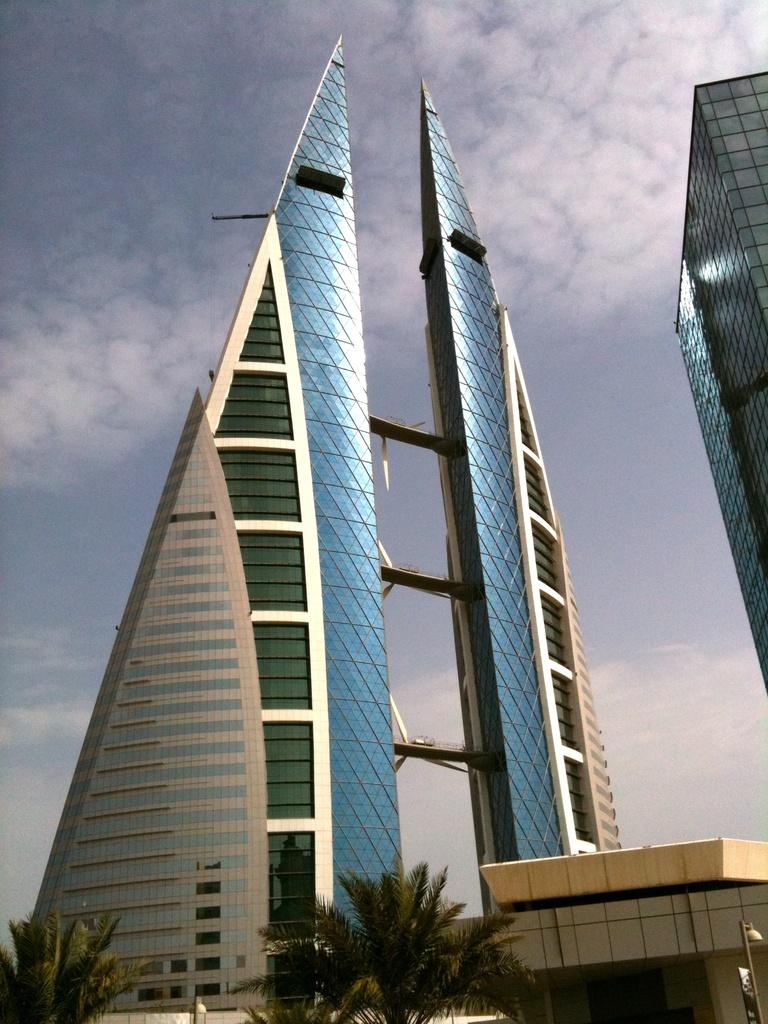What type of vegetation can be seen in the image? There are trees in the image. What is the source of light in the image? There is a light on a pole in the image. What type of structures are visible in the image? There are buildings in the image. What is visible in the background of the image? The sky is visible in the background of the image. What can be observed in the sky? Clouds are present in the sky. What territory does the father claim in the image? There is no reference to a father or territory in the image. What type of payment is required to enter the area depicted in the image? There is no indication of any payment or entrance requirement in the image. 